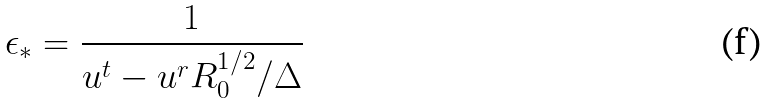<formula> <loc_0><loc_0><loc_500><loc_500>\epsilon _ { * } = \frac { 1 } { u ^ { t } - u ^ { r } R _ { 0 } ^ { 1 / 2 } / \Delta }</formula> 